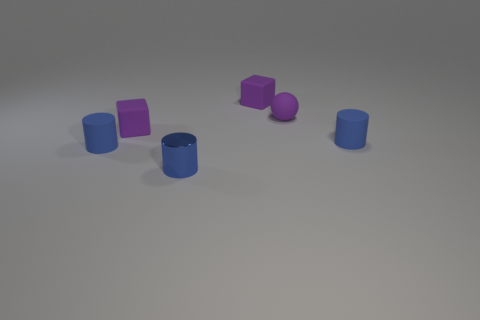How many red objects are rubber things or small things?
Your answer should be compact. 0. Is the number of tiny matte cylinders behind the metallic cylinder the same as the number of tiny purple things?
Your answer should be very brief. No. What number of objects are either matte spheres or small purple objects behind the tiny matte ball?
Provide a short and direct response. 2. Is the matte ball the same color as the metallic cylinder?
Your answer should be very brief. No. Are there any small purple things that have the same material as the ball?
Give a very brief answer. Yes. Is the ball made of the same material as the tiny cube to the right of the small metal object?
Keep it short and to the point. Yes. There is a blue matte object that is on the left side of the purple matte block that is to the right of the small shiny cylinder; what shape is it?
Keep it short and to the point. Cylinder. Is the size of the metal cylinder in front of the purple matte ball the same as the purple ball?
Your response must be concise. Yes. How many other objects are the same shape as the small blue metal thing?
Give a very brief answer. 2. Do the object right of the small sphere and the tiny ball have the same color?
Make the answer very short. No. 